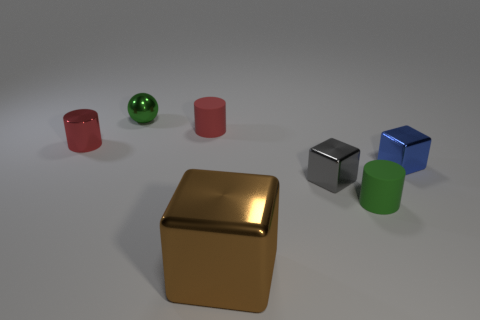Is there anything else that is the same size as the brown metal thing?
Ensure brevity in your answer.  No. What number of rubber objects are the same color as the shiny cylinder?
Provide a short and direct response. 1. Do the small metal cylinder and the rubber cylinder to the left of the gray metal cube have the same color?
Offer a terse response. Yes. How many things are either purple matte objects or small shiny objects that are in front of the small red matte cylinder?
Your answer should be compact. 3. There is a green thing in front of the tiny matte thing that is left of the gray shiny block; what size is it?
Make the answer very short. Small. Is the number of gray shiny objects in front of the small green cylinder the same as the number of big brown cubes that are left of the big metal block?
Your answer should be very brief. Yes. Are there any tiny cylinders on the right side of the small red object that is left of the small shiny sphere?
Keep it short and to the point. Yes. What is the shape of the other blue thing that is the same material as the big object?
Make the answer very short. Cube. Is there anything else that has the same color as the shiny cylinder?
Your answer should be compact. Yes. There is a cylinder on the right side of the matte cylinder that is behind the gray cube; what is its material?
Your response must be concise. Rubber. 